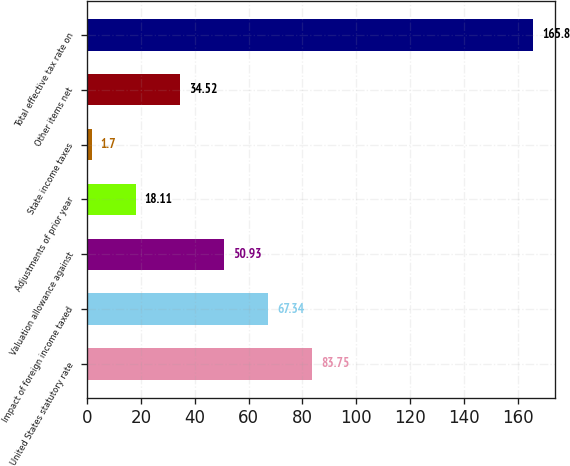<chart> <loc_0><loc_0><loc_500><loc_500><bar_chart><fcel>United States statutory rate<fcel>Impact of foreign income taxed<fcel>Valuation allowance against<fcel>Adjustments of prior year<fcel>State income taxes<fcel>Other items net<fcel>Total effective tax rate on<nl><fcel>83.75<fcel>67.34<fcel>50.93<fcel>18.11<fcel>1.7<fcel>34.52<fcel>165.8<nl></chart> 